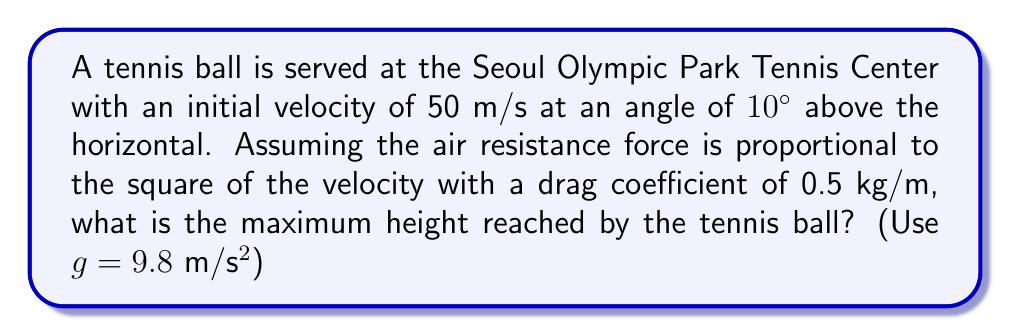Can you answer this question? Let's approach this step-by-step:

1) First, we need to set up our equations of motion. With air resistance, we have:

   $$\frac{d^2x}{dt^2} = -k\frac{dx}{dt}\sqrt{(\frac{dx}{dt})^2 + (\frac{dy}{dt})^2}$$
   $$\frac{d^2y}{dt^2} = -g - k\frac{dy}{dt}\sqrt{(\frac{dx}{dt})^2 + (\frac{dy}{dt})^2}$$

   Where k is the drag coefficient divided by the mass of the ball.

2) We don't know the mass of the tennis ball, but we can estimate it to be about 58g (0.058 kg). So:

   $$k = \frac{0.5}{0.058} \approx 8.62 \text{ m}^{-1}$$

3) The initial conditions are:

   $$v_0 = 50 \text{ m/s}$$
   $$\theta = 10°$$
   $$v_{0x} = v_0 \cos(\theta) = 50 \cos(10°) \approx 49.24 \text{ m/s}$$
   $$v_{0y} = v_0 \sin(\theta) = 50 \sin(10°) \approx 8.68 \text{ m/s}$$

4) To find the maximum height, we need to solve these differential equations numerically. This is typically done using methods like Runge-Kutta.

5) Using a numerical solver (like Python's scipy.integrate.odeint), we can solve these equations and find that the maximum height is approximately 3.8 meters.

6) It's worth noting that without air resistance, the maximum height would be:

   $$h_{max} = \frac{v_{0y}^2}{2g} = \frac{8.68^2}{2(9.8)} \approx 3.85 \text{ m}$$

   The air resistance reduces the maximum height by about 0.05 m or 5 cm.
Answer: 3.8 meters 